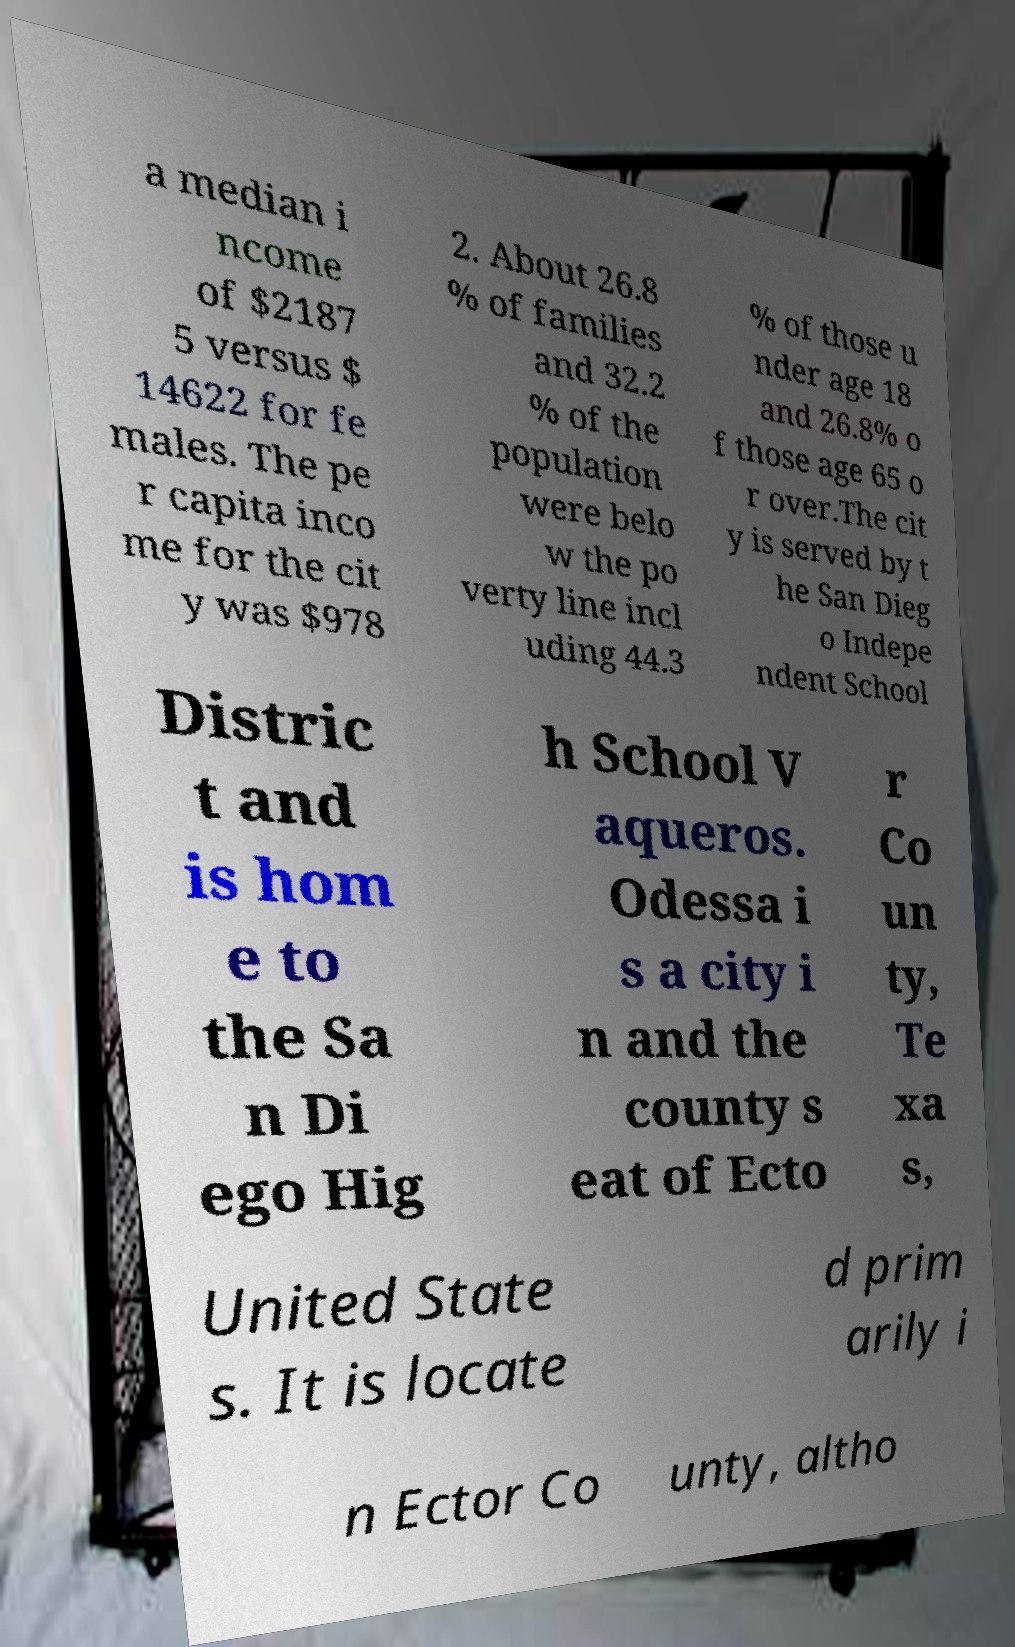Could you assist in decoding the text presented in this image and type it out clearly? a median i ncome of $2187 5 versus $ 14622 for fe males. The pe r capita inco me for the cit y was $978 2. About 26.8 % of families and 32.2 % of the population were belo w the po verty line incl uding 44.3 % of those u nder age 18 and 26.8% o f those age 65 o r over.The cit y is served by t he San Dieg o Indepe ndent School Distric t and is hom e to the Sa n Di ego Hig h School V aqueros. Odessa i s a city i n and the county s eat of Ecto r Co un ty, Te xa s, United State s. It is locate d prim arily i n Ector Co unty, altho 